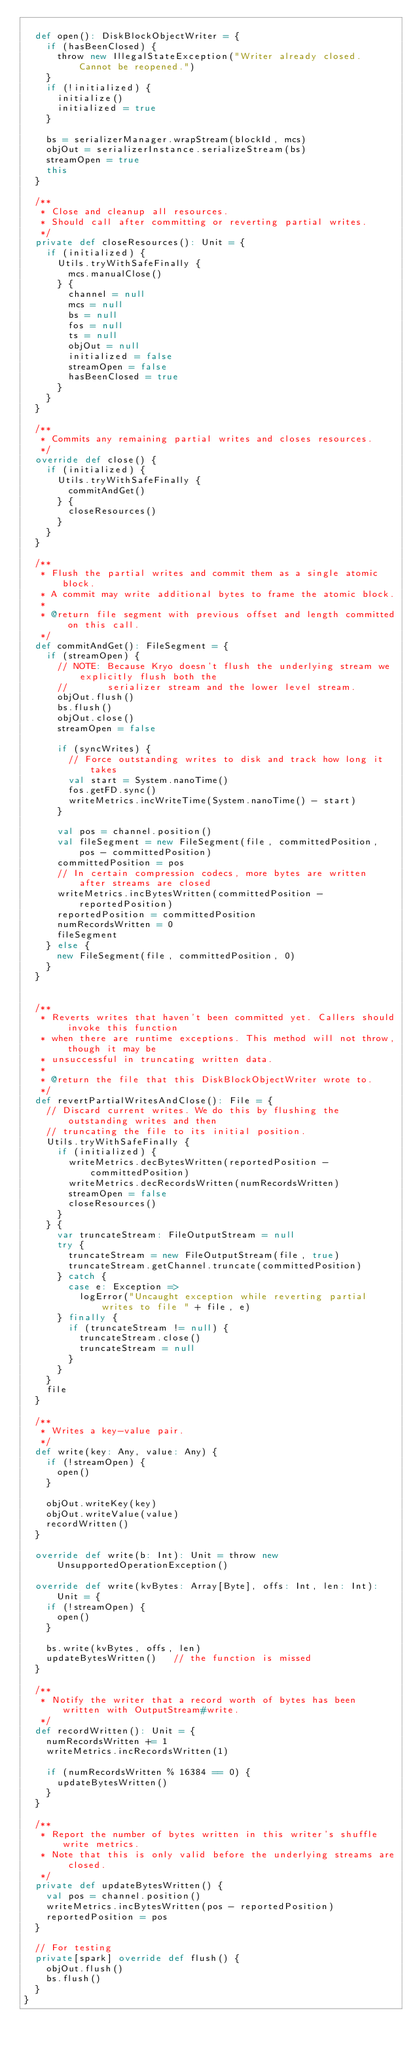Convert code to text. <code><loc_0><loc_0><loc_500><loc_500><_Scala_>
  def open(): DiskBlockObjectWriter = {
    if (hasBeenClosed) {
      throw new IllegalStateException("Writer already closed. Cannot be reopened.")
    }
    if (!initialized) {
      initialize()
      initialized = true
    }

    bs = serializerManager.wrapStream(blockId, mcs)
    objOut = serializerInstance.serializeStream(bs)
    streamOpen = true
    this
  }

  /**
   * Close and cleanup all resources.
   * Should call after committing or reverting partial writes.
   */
  private def closeResources(): Unit = {
    if (initialized) {
      Utils.tryWithSafeFinally {
        mcs.manualClose()
      } {
        channel = null
        mcs = null
        bs = null
        fos = null
        ts = null
        objOut = null
        initialized = false
        streamOpen = false
        hasBeenClosed = true
      }
    }
  }

  /**
   * Commits any remaining partial writes and closes resources.
   */
  override def close() {
    if (initialized) {
      Utils.tryWithSafeFinally {
        commitAndGet()
      } {
        closeResources()
      }
    }
  }

  /**
   * Flush the partial writes and commit them as a single atomic block.
   * A commit may write additional bytes to frame the atomic block.
   *
   * @return file segment with previous offset and length committed on this call.
   */
  def commitAndGet(): FileSegment = {
    if (streamOpen) {
      // NOTE: Because Kryo doesn't flush the underlying stream we explicitly flush both the
      //       serializer stream and the lower level stream.
      objOut.flush()
      bs.flush()
      objOut.close()
      streamOpen = false

      if (syncWrites) {
        // Force outstanding writes to disk and track how long it takes
        val start = System.nanoTime()
        fos.getFD.sync()
        writeMetrics.incWriteTime(System.nanoTime() - start)
      }

      val pos = channel.position()
      val fileSegment = new FileSegment(file, committedPosition, pos - committedPosition)
      committedPosition = pos
      // In certain compression codecs, more bytes are written after streams are closed
      writeMetrics.incBytesWritten(committedPosition - reportedPosition)
      reportedPosition = committedPosition
      numRecordsWritten = 0
      fileSegment
    } else {
      new FileSegment(file, committedPosition, 0)
    }
  }


  /**
   * Reverts writes that haven't been committed yet. Callers should invoke this function
   * when there are runtime exceptions. This method will not throw, though it may be
   * unsuccessful in truncating written data.
   *
   * @return the file that this DiskBlockObjectWriter wrote to.
   */
  def revertPartialWritesAndClose(): File = {
    // Discard current writes. We do this by flushing the outstanding writes and then
    // truncating the file to its initial position.
    Utils.tryWithSafeFinally {
      if (initialized) {
        writeMetrics.decBytesWritten(reportedPosition - committedPosition)
        writeMetrics.decRecordsWritten(numRecordsWritten)
        streamOpen = false
        closeResources()
      }
    } {
      var truncateStream: FileOutputStream = null
      try {
        truncateStream = new FileOutputStream(file, true)
        truncateStream.getChannel.truncate(committedPosition)
      } catch {
        case e: Exception =>
          logError("Uncaught exception while reverting partial writes to file " + file, e)
      } finally {
        if (truncateStream != null) {
          truncateStream.close()
          truncateStream = null
        }
      }
    }
    file
  }

  /**
   * Writes a key-value pair.
   */
  def write(key: Any, value: Any) {
    if (!streamOpen) {
      open()
    }

    objOut.writeKey(key)
    objOut.writeValue(value)
    recordWritten()
  }

  override def write(b: Int): Unit = throw new UnsupportedOperationException()

  override def write(kvBytes: Array[Byte], offs: Int, len: Int): Unit = {
    if (!streamOpen) {
      open()
    }

    bs.write(kvBytes, offs, len)
    updateBytesWritten()   // the function is missed
  }

  /**
   * Notify the writer that a record worth of bytes has been written with OutputStream#write.
   */
  def recordWritten(): Unit = {
    numRecordsWritten += 1
    writeMetrics.incRecordsWritten(1)

    if (numRecordsWritten % 16384 == 0) {
      updateBytesWritten()
    }
  }

  /**
   * Report the number of bytes written in this writer's shuffle write metrics.
   * Note that this is only valid before the underlying streams are closed.
   */
  private def updateBytesWritten() {
    val pos = channel.position()
    writeMetrics.incBytesWritten(pos - reportedPosition)
    reportedPosition = pos
  }

  // For testing
  private[spark] override def flush() {
    objOut.flush()
    bs.flush()
  }
}
</code> 